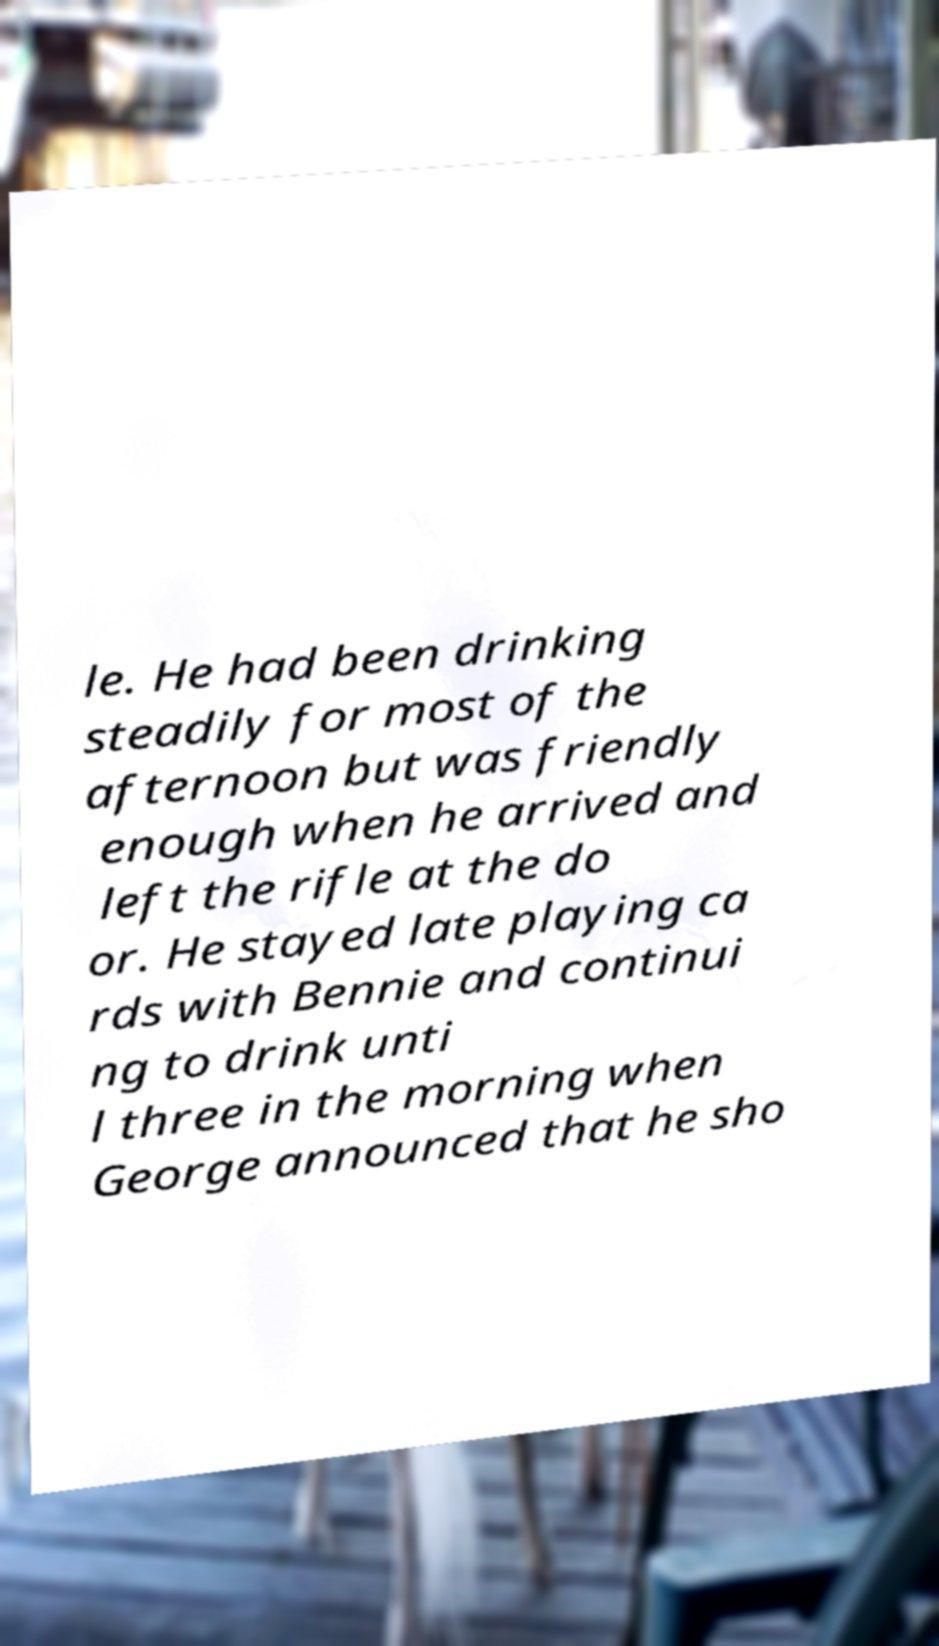Please identify and transcribe the text found in this image. le. He had been drinking steadily for most of the afternoon but was friendly enough when he arrived and left the rifle at the do or. He stayed late playing ca rds with Bennie and continui ng to drink unti l three in the morning when George announced that he sho 